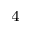Convert formula to latex. <formula><loc_0><loc_0><loc_500><loc_500>^ { 4 }</formula> 